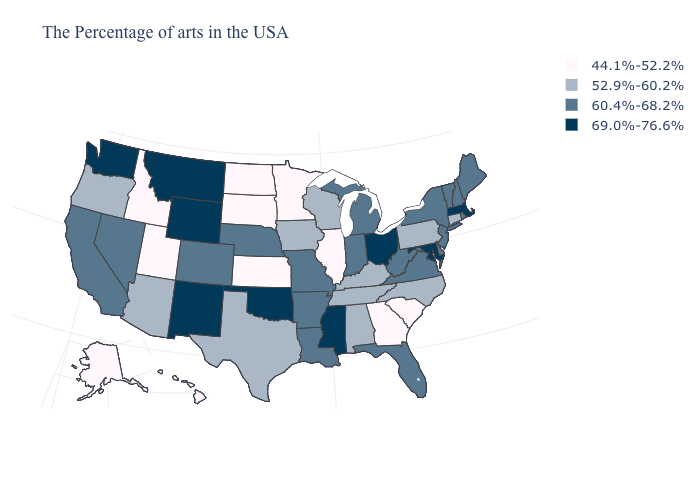Name the states that have a value in the range 52.9%-60.2%?
Quick response, please. Connecticut, Pennsylvania, North Carolina, Kentucky, Alabama, Tennessee, Wisconsin, Iowa, Texas, Arizona, Oregon. How many symbols are there in the legend?
Short answer required. 4. Does Wyoming have the lowest value in the USA?
Give a very brief answer. No. Does California have a lower value than Montana?
Answer briefly. Yes. What is the value of Minnesota?
Write a very short answer. 44.1%-52.2%. Among the states that border Alabama , does Tennessee have the lowest value?
Write a very short answer. No. What is the lowest value in the USA?
Short answer required. 44.1%-52.2%. What is the value of West Virginia?
Concise answer only. 60.4%-68.2%. Name the states that have a value in the range 60.4%-68.2%?
Keep it brief. Maine, Rhode Island, New Hampshire, Vermont, New York, New Jersey, Delaware, Virginia, West Virginia, Florida, Michigan, Indiana, Louisiana, Missouri, Arkansas, Nebraska, Colorado, Nevada, California. What is the lowest value in states that border Nevada?
Quick response, please. 44.1%-52.2%. Which states have the lowest value in the Northeast?
Write a very short answer. Connecticut, Pennsylvania. What is the value of Utah?
Answer briefly. 44.1%-52.2%. What is the value of Nevada?
Answer briefly. 60.4%-68.2%. How many symbols are there in the legend?
Short answer required. 4. Name the states that have a value in the range 44.1%-52.2%?
Keep it brief. South Carolina, Georgia, Illinois, Minnesota, Kansas, South Dakota, North Dakota, Utah, Idaho, Alaska, Hawaii. 